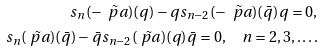<formula> <loc_0><loc_0><loc_500><loc_500>s _ { n } ( - \tilde { \ p a } ) ( q ) - q s _ { n - 2 } ( - \tilde { \ p a } ) ( \bar { q } ) q = 0 , \\ s _ { n } ( \tilde { \ p a } ) ( \bar { q } ) - \bar { q } s _ { n - 2 } ( \tilde { \ p a } ) ( q ) \bar { q } = 0 , \quad n = 2 , 3 , \dots .</formula> 